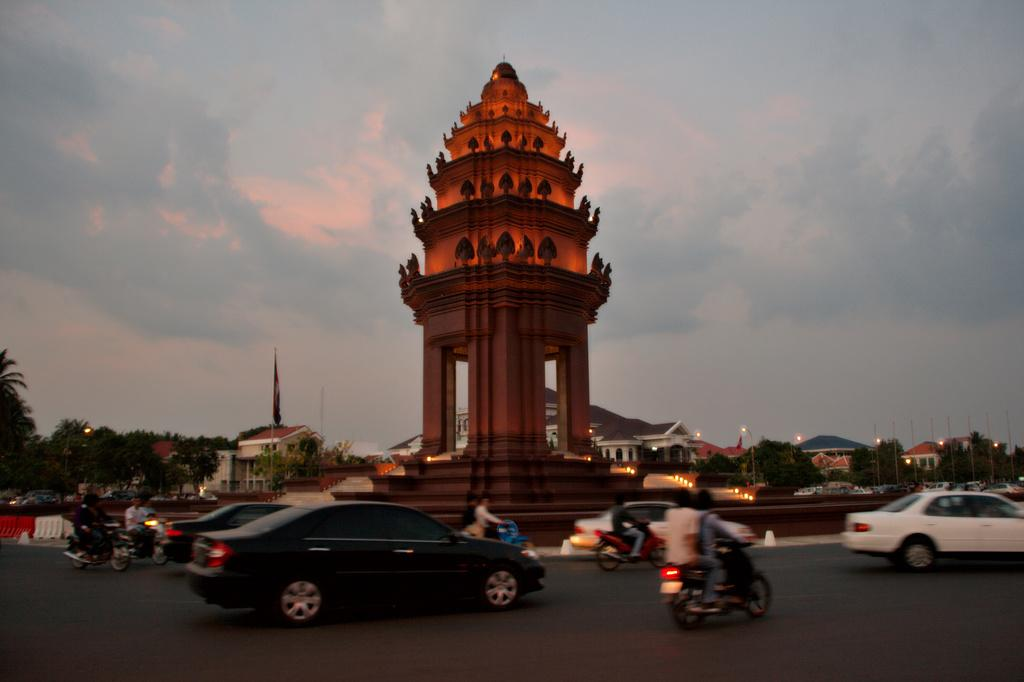What is happening on the road in the image? There are vehicles moving on the road in the image. What type of structure can be seen in the image? There is an architecture visible in the image. What can be seen illuminating the scene in the image? Lights are present in the image. What national symbols are present in the image? There are flags in the image. What type of residential buildings can be seen in the image? Houses are visible in the image. What type of vegetation is present in the image? Trees are present in the image. What is visible in the background of the image? The sky with clouds is visible in the background of the image. Can you tell me how many chess pieces are on the table in the image? There is no table or chess pieces present in the image. Are there any people swimming in the image? There is no swimming or water visible in the image. 